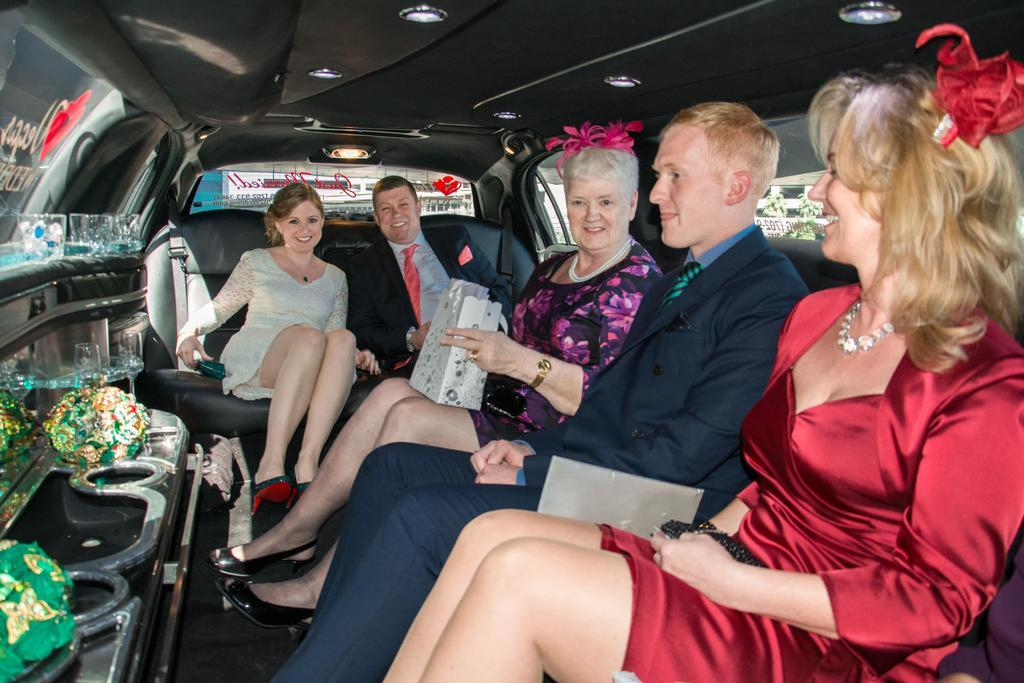What are the people inside the car doing? The people are sitting inside the car. What are the people holding while sitting in the car? The people are holding bags. Can you describe the car's features? There is a window on the right side of the car. What type of locket is the person wearing in the image? There is no locket visible in the image; it only shows people sitting inside a car holding bags. 